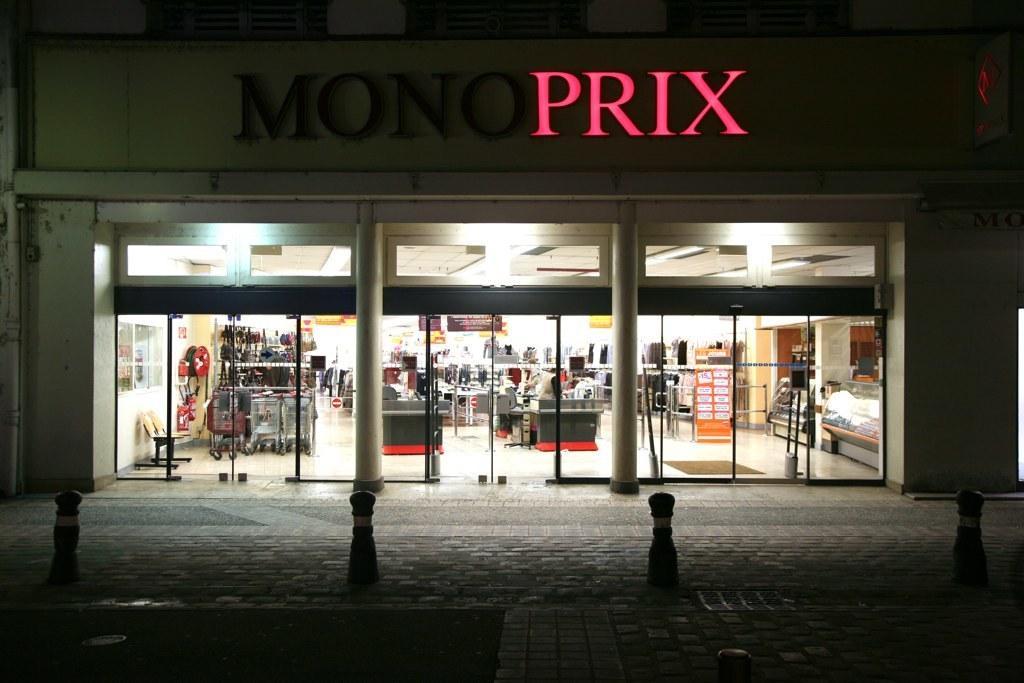Describe this image in one or two sentences. In this picture we can see metal poles on the ground and in the background we can see a building with a name on it, here we can see chairs, wall, posters, lights, glass doors and some objects. 